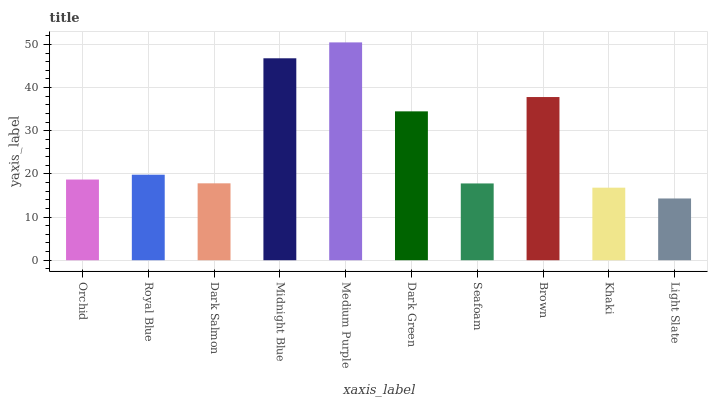Is Light Slate the minimum?
Answer yes or no. Yes. Is Medium Purple the maximum?
Answer yes or no. Yes. Is Royal Blue the minimum?
Answer yes or no. No. Is Royal Blue the maximum?
Answer yes or no. No. Is Royal Blue greater than Orchid?
Answer yes or no. Yes. Is Orchid less than Royal Blue?
Answer yes or no. Yes. Is Orchid greater than Royal Blue?
Answer yes or no. No. Is Royal Blue less than Orchid?
Answer yes or no. No. Is Royal Blue the high median?
Answer yes or no. Yes. Is Orchid the low median?
Answer yes or no. Yes. Is Midnight Blue the high median?
Answer yes or no. No. Is Light Slate the low median?
Answer yes or no. No. 